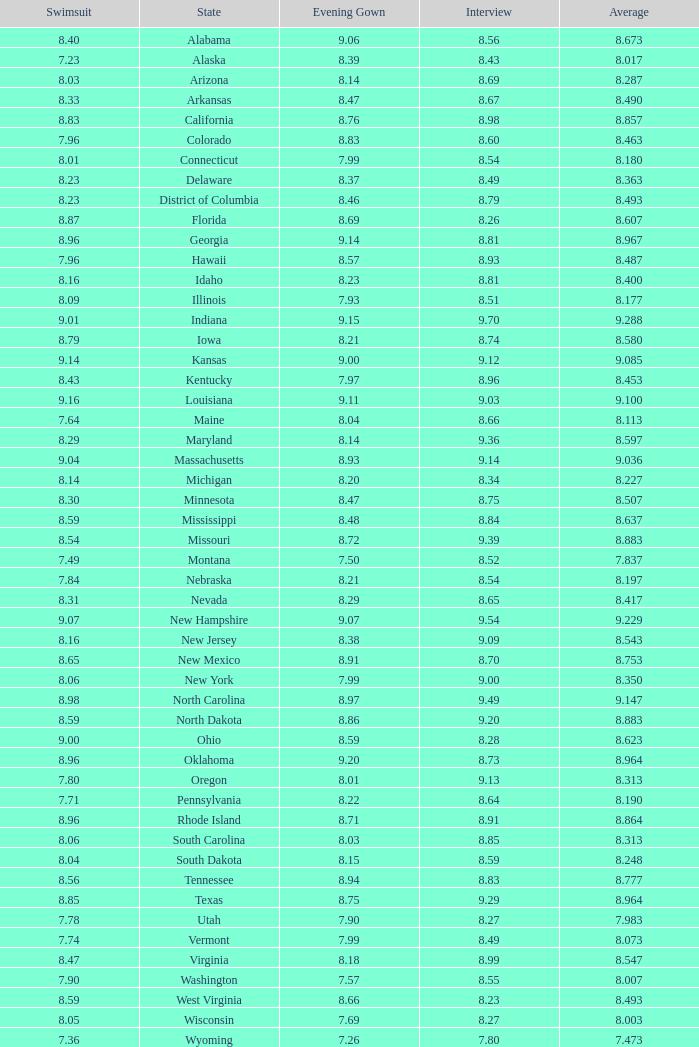Name the total number of swimsuits for evening gowns less than 8.21 and average of 8.453 with interview less than 9.09 1.0. 